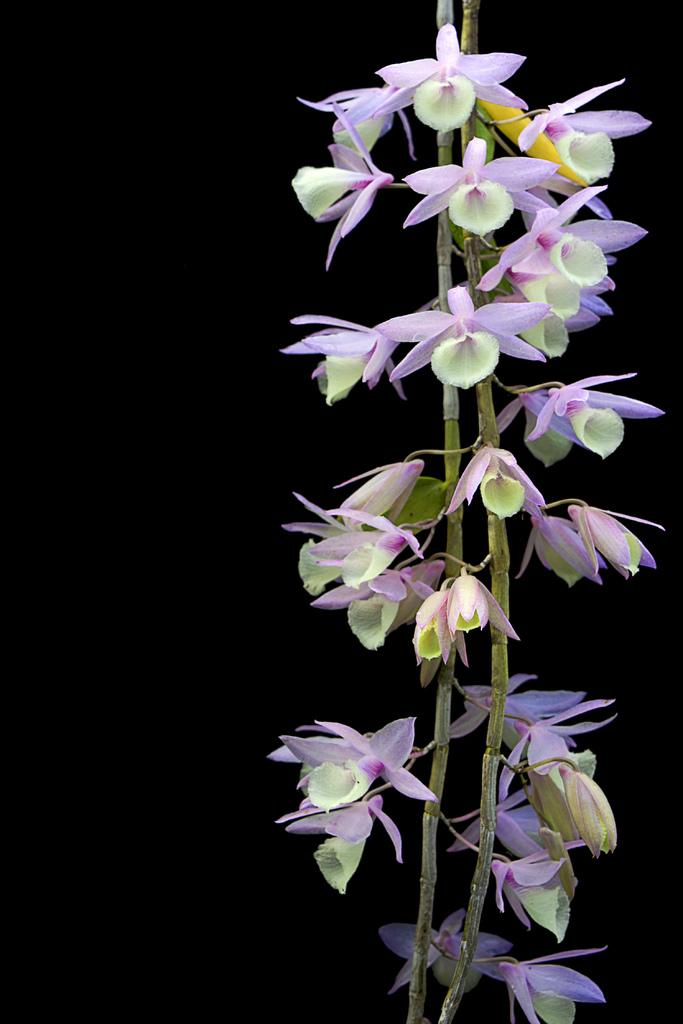What is present in the image? There is a plant in the image. What specific feature of the plant can be observed? The plant has flowers. What color are the flowers? The flowers are purple in color. How would you describe the background of the image? The background of the image is dark. What type of cough medicine is on the table in the image? There is no cough medicine or table present in the image; it features a plant with purple flowers and a dark background. 